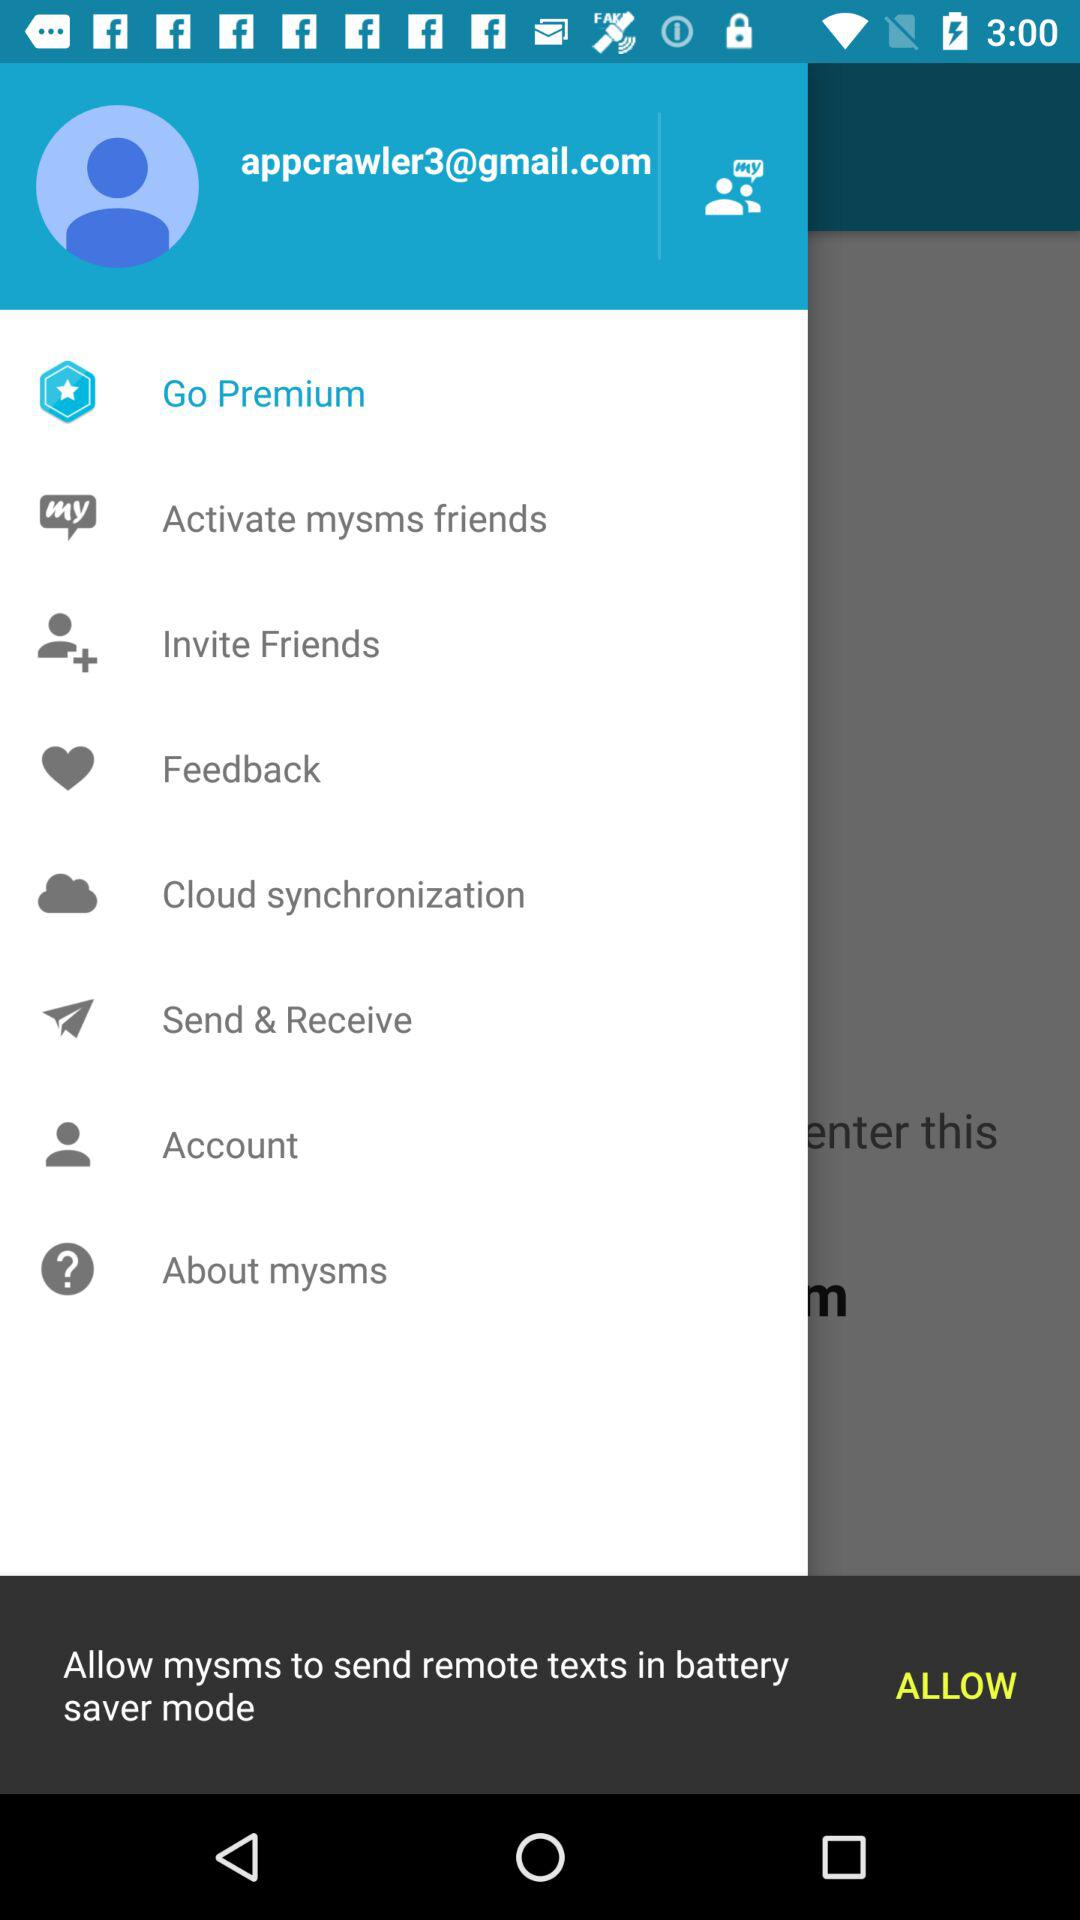What is the email address? The email address is appcrawler3@gmail.com. 